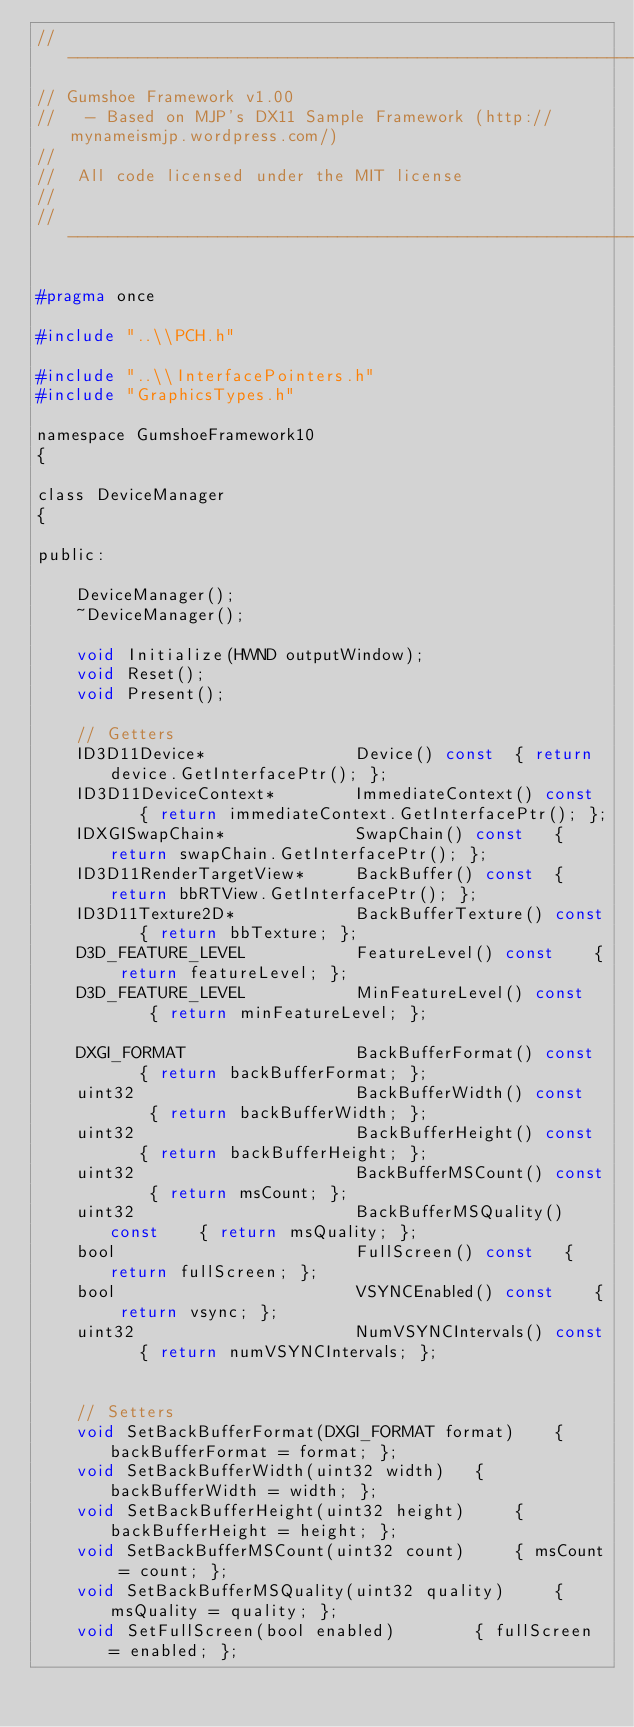Convert code to text. <code><loc_0><loc_0><loc_500><loc_500><_C_>//-------------------------------------------------------------------------------
// Gumshoe Framework v1.00
//   - Based on MJP's DX11 Sample Framework (http://mynameismjp.wordpress.com/)
//
//  All code licensed under the MIT license
//
//-------------------------------------------------------------------------------

#pragma once

#include "..\\PCH.h"

#include "..\\InterfacePointers.h"
#include "GraphicsTypes.h"

namespace GumshoeFramework10
{

class DeviceManager
{

public:

    DeviceManager();
    ~DeviceManager();

    void Initialize(HWND outputWindow);
    void Reset();
    void Present();

    // Getters
    ID3D11Device*               Device() const  { return device.GetInterfacePtr(); };
    ID3D11DeviceContext*        ImmediateContext() const    { return immediateContext.GetInterfacePtr(); };
    IDXGISwapChain*             SwapChain() const   { return swapChain.GetInterfacePtr(); };
    ID3D11RenderTargetView*     BackBuffer() const  { return bbRTView.GetInterfacePtr(); };
    ID3D11Texture2D*            BackBufferTexture() const   { return bbTexture; };
    D3D_FEATURE_LEVEL           FeatureLevel() const    { return featureLevel; };
    D3D_FEATURE_LEVEL           MinFeatureLevel() const     { return minFeatureLevel; };

    DXGI_FORMAT                 BackBufferFormat() const    { return backBufferFormat; };
    uint32                      BackBufferWidth() const     { return backBufferWidth; };
    uint32                      BackBufferHeight() const    { return backBufferHeight; };
    uint32                      BackBufferMSCount() const    { return msCount; };
    uint32                      BackBufferMSQuality() const    { return msQuality; };
    bool                        FullScreen() const   { return fullScreen; };
    bool                        VSYNCEnabled() const    { return vsync; };
    uint32                      NumVSYNCIntervals() const   { return numVSYNCIntervals; };


    // Setters
    void SetBackBufferFormat(DXGI_FORMAT format)    { backBufferFormat = format; };
    void SetBackBufferWidth(uint32 width)   { backBufferWidth = width; };
    void SetBackBufferHeight(uint32 height)     { backBufferHeight = height; };
    void SetBackBufferMSCount(uint32 count)     { msCount = count; };
    void SetBackBufferMSQuality(uint32 quality)     { msQuality = quality; };
    void SetFullScreen(bool enabled)        { fullScreen = enabled; };</code> 